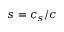Convert formula to latex. <formula><loc_0><loc_0><loc_500><loc_500>s = c _ { s } / c</formula> 